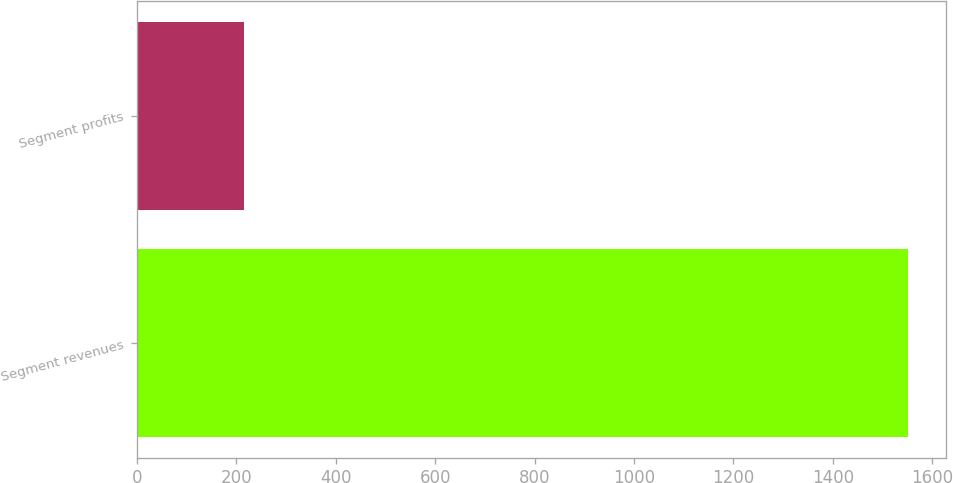<chart> <loc_0><loc_0><loc_500><loc_500><bar_chart><fcel>Segment revenues<fcel>Segment profits<nl><fcel>1551<fcel>216<nl></chart> 